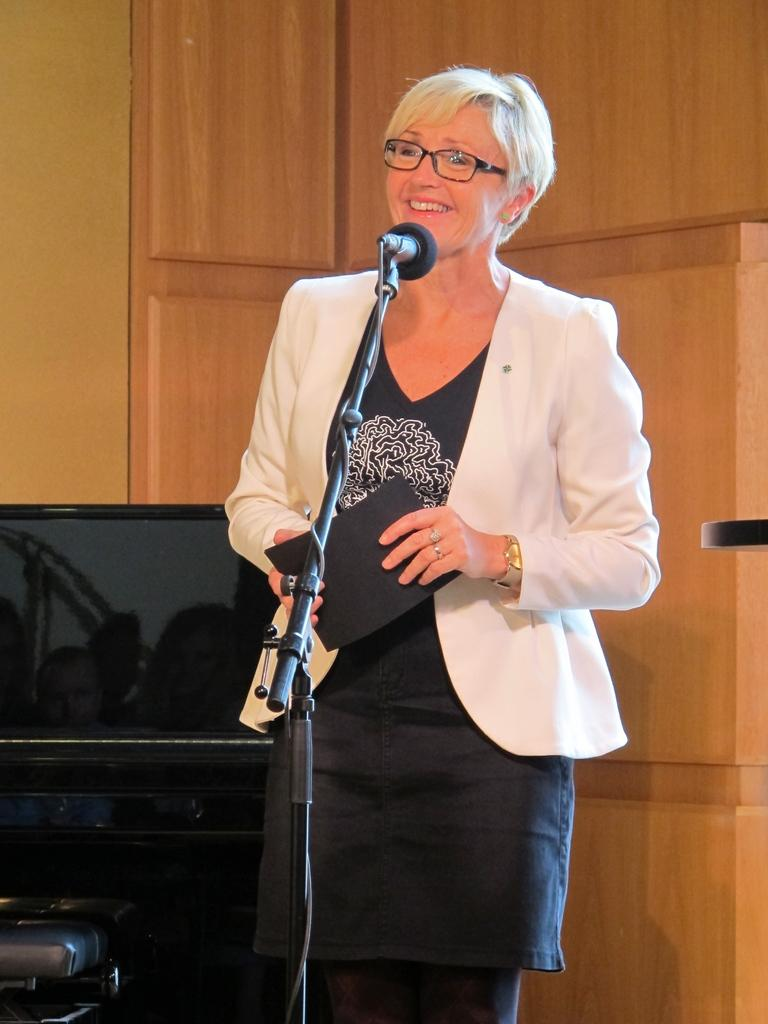Who or what is present in the image? There is a person in the image. What is the person holding? The person is holding a card. What can be seen near the person? There is a microphone attached to a stand and an object beside the person. What electronic device is visible in the image? There is a computer in the image. What type of furniture is present in the image? There are cupboards in the image. How comfortable is the person's feet in the image? The image does not provide information about the person's feet or their comfort level. 